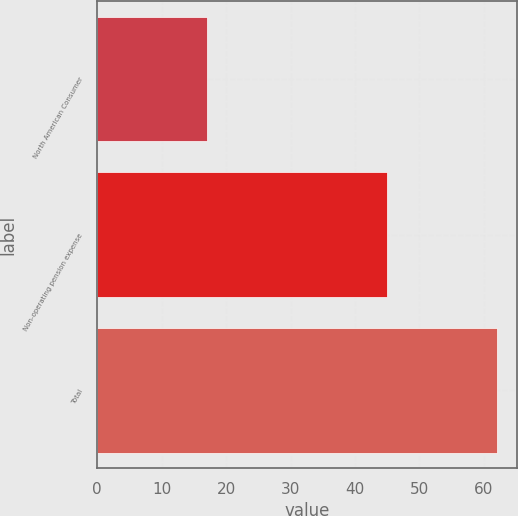Convert chart to OTSL. <chart><loc_0><loc_0><loc_500><loc_500><bar_chart><fcel>North American Consumer<fcel>Non-operating pension expense<fcel>Total<nl><fcel>17<fcel>45<fcel>62<nl></chart> 